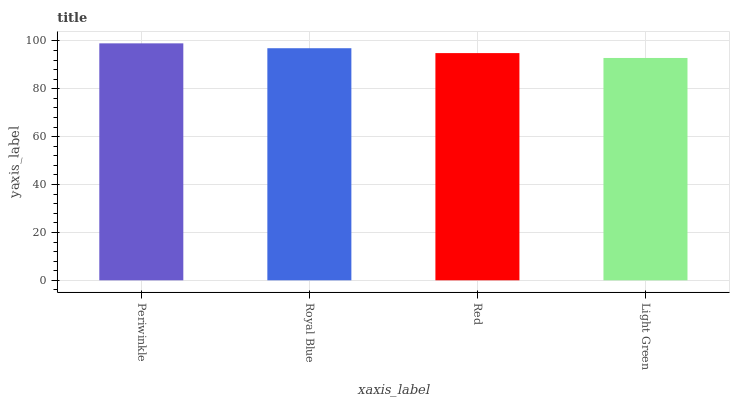Is Light Green the minimum?
Answer yes or no. Yes. Is Periwinkle the maximum?
Answer yes or no. Yes. Is Royal Blue the minimum?
Answer yes or no. No. Is Royal Blue the maximum?
Answer yes or no. No. Is Periwinkle greater than Royal Blue?
Answer yes or no. Yes. Is Royal Blue less than Periwinkle?
Answer yes or no. Yes. Is Royal Blue greater than Periwinkle?
Answer yes or no. No. Is Periwinkle less than Royal Blue?
Answer yes or no. No. Is Royal Blue the high median?
Answer yes or no. Yes. Is Red the low median?
Answer yes or no. Yes. Is Red the high median?
Answer yes or no. No. Is Light Green the low median?
Answer yes or no. No. 